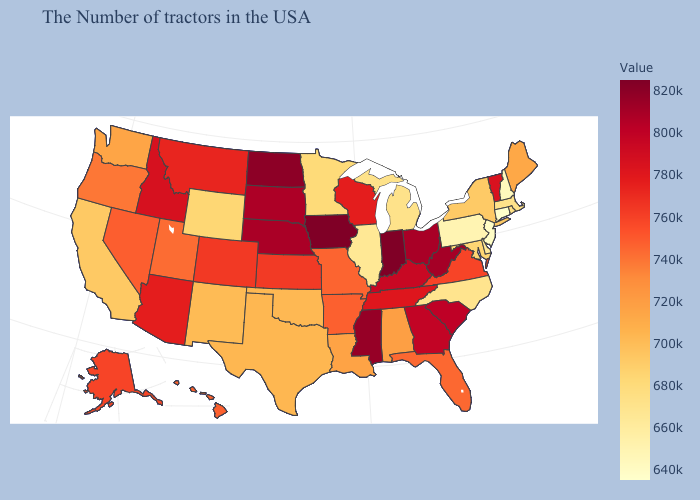Does California have the highest value in the West?
Write a very short answer. No. Does Mississippi have the highest value in the South?
Give a very brief answer. Yes. Does Oregon have the highest value in the USA?
Answer briefly. No. 